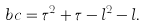<formula> <loc_0><loc_0><loc_500><loc_500>b c = \tau ^ { 2 } + \tau - l ^ { 2 } - l .</formula> 